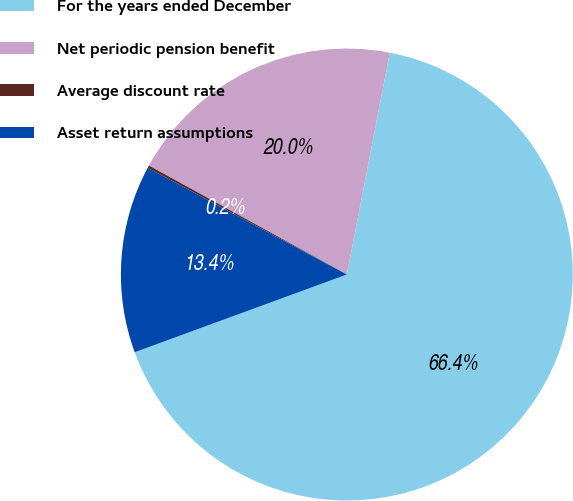Convert chart. <chart><loc_0><loc_0><loc_500><loc_500><pie_chart><fcel>For the years ended December<fcel>Net periodic pension benefit<fcel>Average discount rate<fcel>Asset return assumptions<nl><fcel>66.37%<fcel>20.04%<fcel>0.18%<fcel>13.42%<nl></chart> 